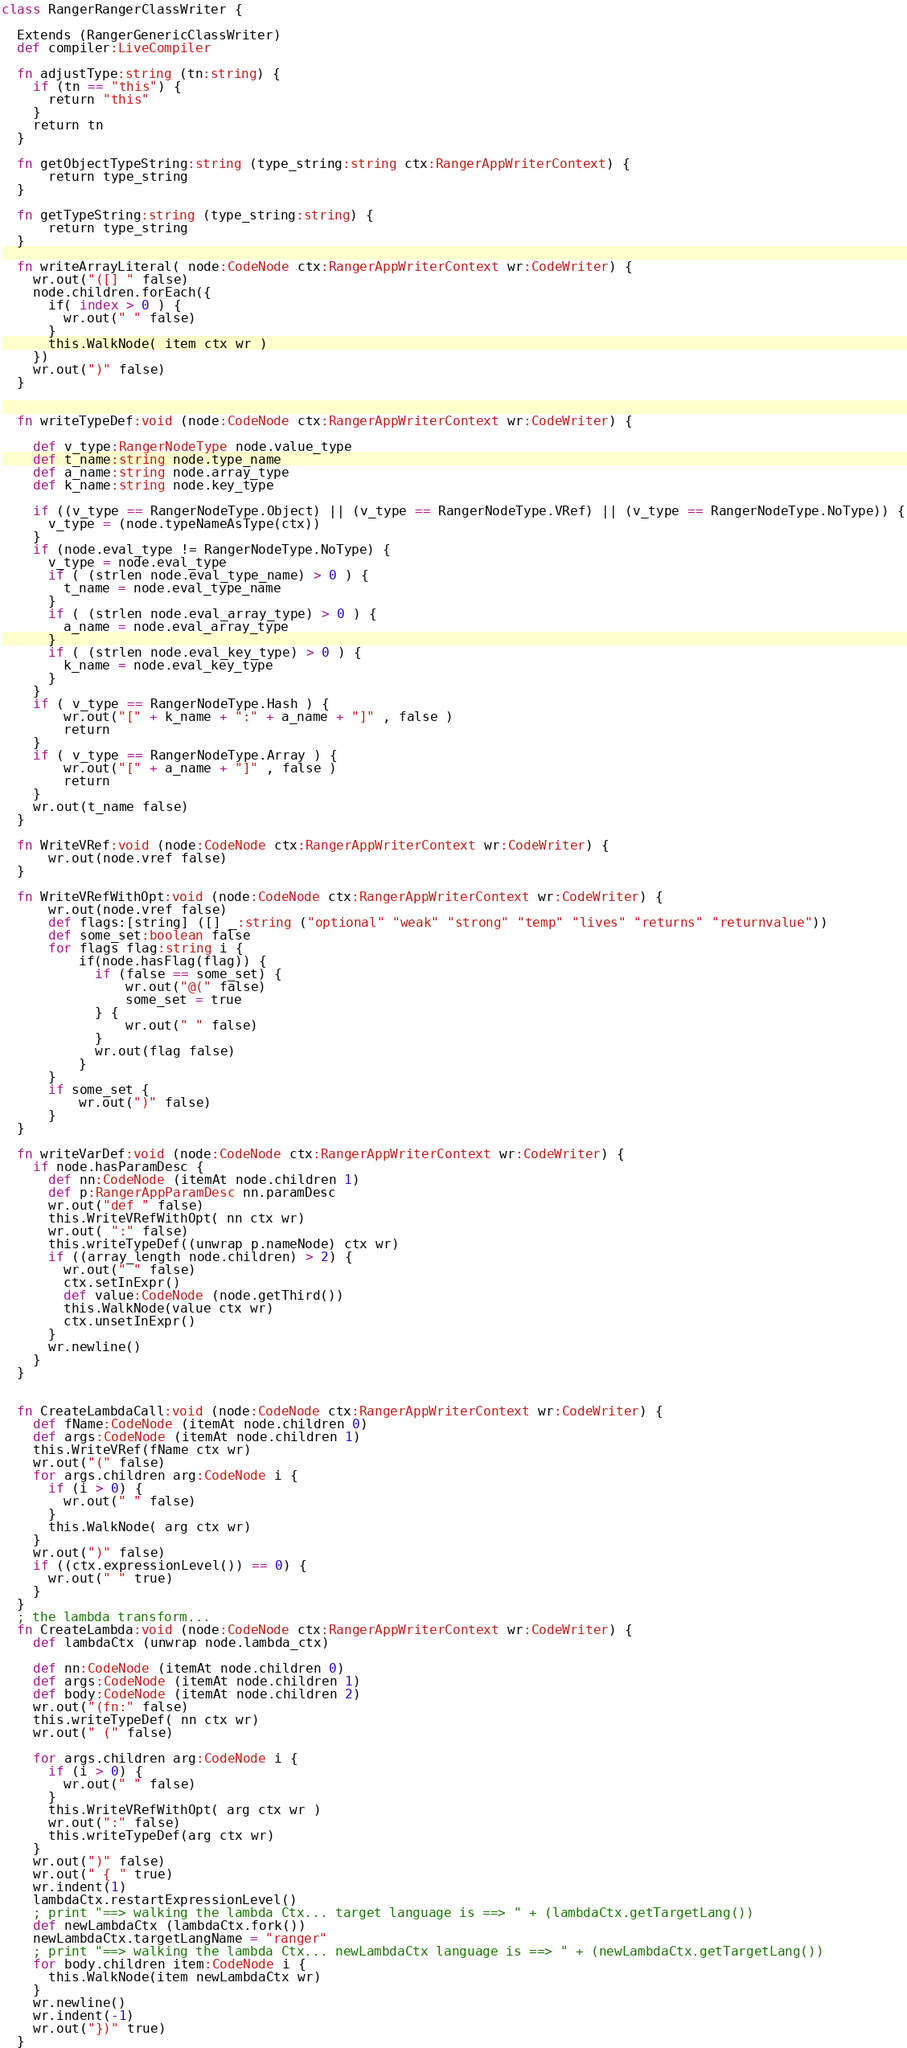Convert code to text. <code><loc_0><loc_0><loc_500><loc_500><_Clojure_>
class RangerRangerClassWriter {

  Extends (RangerGenericClassWriter)
  def compiler:LiveCompiler

  fn adjustType:string (tn:string) {
    if (tn == "this") {
      return "this"
    } 
    return tn
  }

  fn getObjectTypeString:string (type_string:string ctx:RangerAppWriterContext) {
      return type_string
  }
  
  fn getTypeString:string (type_string:string) {
      return type_string
  }

  fn writeArrayLiteral( node:CodeNode ctx:RangerAppWriterContext wr:CodeWriter) {
    wr.out("([] " false)
    node.children.forEach({
      if( index > 0 ) {
        wr.out(" " false)
      }
      this.WalkNode( item ctx wr )
    })
    wr.out(")" false)
  }
  

  fn writeTypeDef:void (node:CodeNode ctx:RangerAppWriterContext wr:CodeWriter) {

    def v_type:RangerNodeType node.value_type    
    def t_name:string node.type_name
    def a_name:string node.array_type
    def k_name:string node.key_type
  
    if ((v_type == RangerNodeType.Object) || (v_type == RangerNodeType.VRef) || (v_type == RangerNodeType.NoType)) {
      v_type = (node.typeNameAsType(ctx))
    }
    if (node.eval_type != RangerNodeType.NoType) {
      v_type = node.eval_type
      if ( (strlen node.eval_type_name) > 0 ) {
        t_name = node.eval_type_name
      }
      if ( (strlen node.eval_array_type) > 0 ) {
        a_name = node.eval_array_type
      }
      if ( (strlen node.eval_key_type) > 0 ) {
        k_name = node.eval_key_type
      }
    }
    if ( v_type == RangerNodeType.Hash ) {
        wr.out("[" + k_name + ":" + a_name + "]" , false )
        return
    }
    if ( v_type == RangerNodeType.Array ) {
        wr.out("[" + a_name + "]" , false )
        return
    }
    wr.out(t_name false)
  }

  fn WriteVRef:void (node:CodeNode ctx:RangerAppWriterContext wr:CodeWriter) {
      wr.out(node.vref false)
  }

  fn WriteVRefWithOpt:void (node:CodeNode ctx:RangerAppWriterContext wr:CodeWriter) {
      wr.out(node.vref false)
      def flags:[string] ([] _:string ("optional" "weak" "strong" "temp" "lives" "returns" "returnvalue"))
      def some_set:boolean false
      for flags flag:string i {
          if(node.hasFlag(flag)) {
            if (false == some_set) {
                wr.out("@(" false)
                some_set = true
            } {
                wr.out(" " false)
            }
            wr.out(flag false)
          }
      }
      if some_set {
          wr.out(")" false)
      }
  }  

  fn writeVarDef:void (node:CodeNode ctx:RangerAppWriterContext wr:CodeWriter) {
    if node.hasParamDesc {
      def nn:CodeNode (itemAt node.children 1)
      def p:RangerAppParamDesc nn.paramDesc
      wr.out("def " false)
      this.WriteVRefWithOpt( nn ctx wr)
      wr.out( ":" false)
      this.writeTypeDef((unwrap p.nameNode) ctx wr)
      if ((array_length node.children) > 2) {
        wr.out(" " false)
        ctx.setInExpr()
        def value:CodeNode (node.getThird())
        this.WalkNode(value ctx wr)
        ctx.unsetInExpr()
      }    
      wr.newline()
    } 
  }


  fn CreateLambdaCall:void (node:CodeNode ctx:RangerAppWriterContext wr:CodeWriter) {
    def fName:CodeNode (itemAt node.children 0)
    def args:CodeNode (itemAt node.children 1)
    this.WriteVRef(fName ctx wr)
    wr.out("(" false)
    for args.children arg:CodeNode i {
      if (i > 0) {
        wr.out(" " false)
      }
      this.WalkNode( arg ctx wr)
    }
    wr.out(")" false)
    if ((ctx.expressionLevel()) == 0) {
      wr.out(" " true)
    }
  }
  ; the lambda transform...
  fn CreateLambda:void (node:CodeNode ctx:RangerAppWriterContext wr:CodeWriter) {
    def lambdaCtx (unwrap node.lambda_ctx)

    def nn:CodeNode (itemAt node.children 0)
    def args:CodeNode (itemAt node.children 1)
    def body:CodeNode (itemAt node.children 2)
    wr.out("(fn:" false)
    this.writeTypeDef( nn ctx wr)
    wr.out(" (" false)

    for args.children arg:CodeNode i {
      if (i > 0) {
        wr.out(" " false)
      }
      this.WriteVRefWithOpt( arg ctx wr )
      wr.out(":" false)
      this.writeTypeDef(arg ctx wr)
    }
    wr.out(")" false)
    wr.out(" { " true)
    wr.indent(1)
    lambdaCtx.restartExpressionLevel()
    ; print "==> walking the lambda Ctx... target language is ==> " + (lambdaCtx.getTargetLang())
    def newLambdaCtx (lambdaCtx.fork())
    newLambdaCtx.targetLangName = "ranger"
    ; print "==> walking the lambda Ctx... newLambdaCtx language is ==> " + (newLambdaCtx.getTargetLang())
    for body.children item:CodeNode i {
      this.WalkNode(item newLambdaCtx wr)
    }
    wr.newline()
    wr.indent(-1)
    wr.out("})" true)
  }</code> 